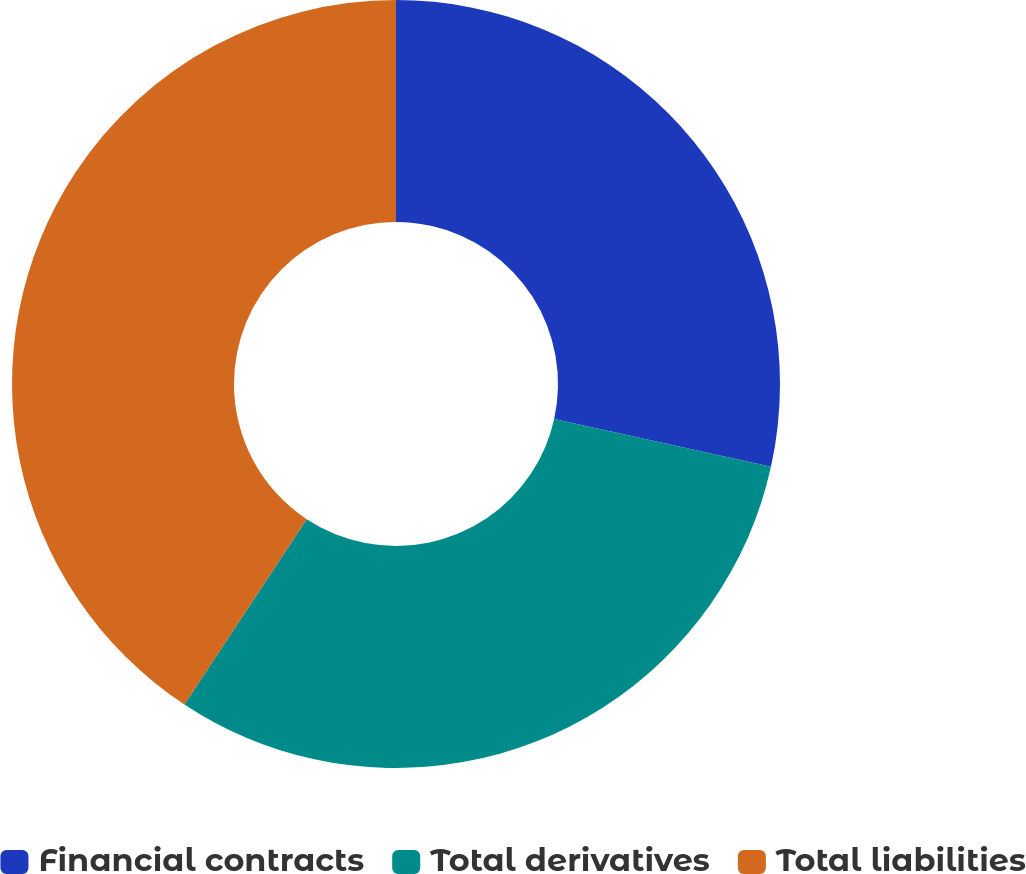<chart> <loc_0><loc_0><loc_500><loc_500><pie_chart><fcel>Financial contracts<fcel>Total derivatives<fcel>Total liabilities<nl><fcel>28.46%<fcel>30.83%<fcel>40.71%<nl></chart> 